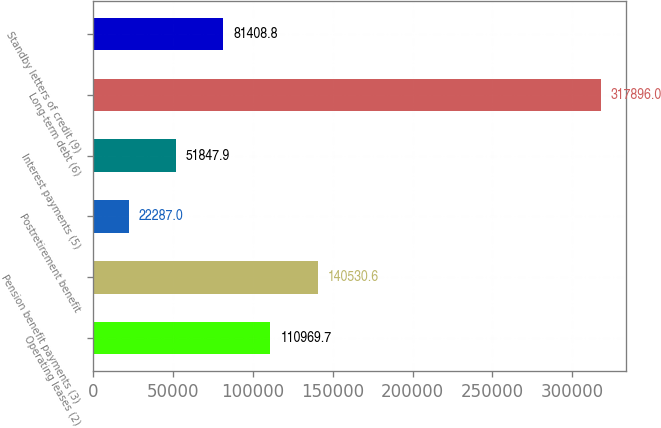Convert chart to OTSL. <chart><loc_0><loc_0><loc_500><loc_500><bar_chart><fcel>Operating leases (2)<fcel>Pension benefit payments (3)<fcel>Postretirement benefit<fcel>Interest payments (5)<fcel>Long-term debt (6)<fcel>Standby letters of credit (9)<nl><fcel>110970<fcel>140531<fcel>22287<fcel>51847.9<fcel>317896<fcel>81408.8<nl></chart> 